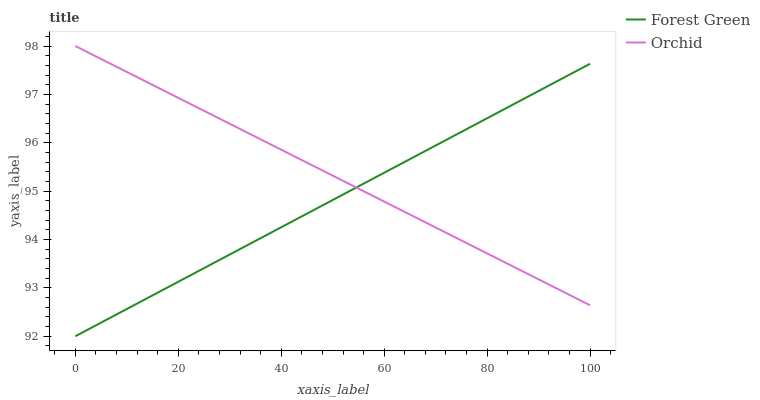Does Forest Green have the minimum area under the curve?
Answer yes or no. Yes. Does Orchid have the maximum area under the curve?
Answer yes or no. Yes. Does Orchid have the minimum area under the curve?
Answer yes or no. No. Is Forest Green the smoothest?
Answer yes or no. Yes. Is Orchid the roughest?
Answer yes or no. Yes. Is Orchid the smoothest?
Answer yes or no. No. Does Orchid have the lowest value?
Answer yes or no. No. 